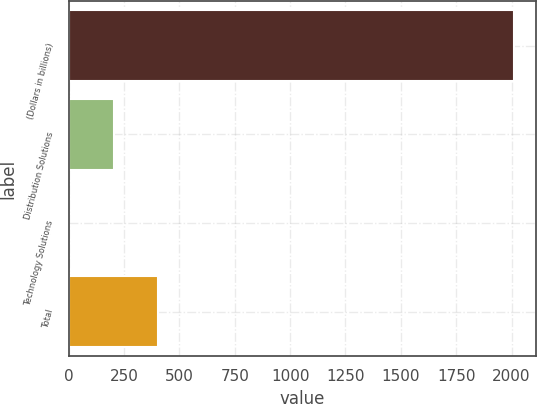<chart> <loc_0><loc_0><loc_500><loc_500><bar_chart><fcel>(Dollars in billions)<fcel>Distribution Solutions<fcel>Technology Solutions<fcel>Total<nl><fcel>2010<fcel>203.79<fcel>3.1<fcel>404.48<nl></chart> 